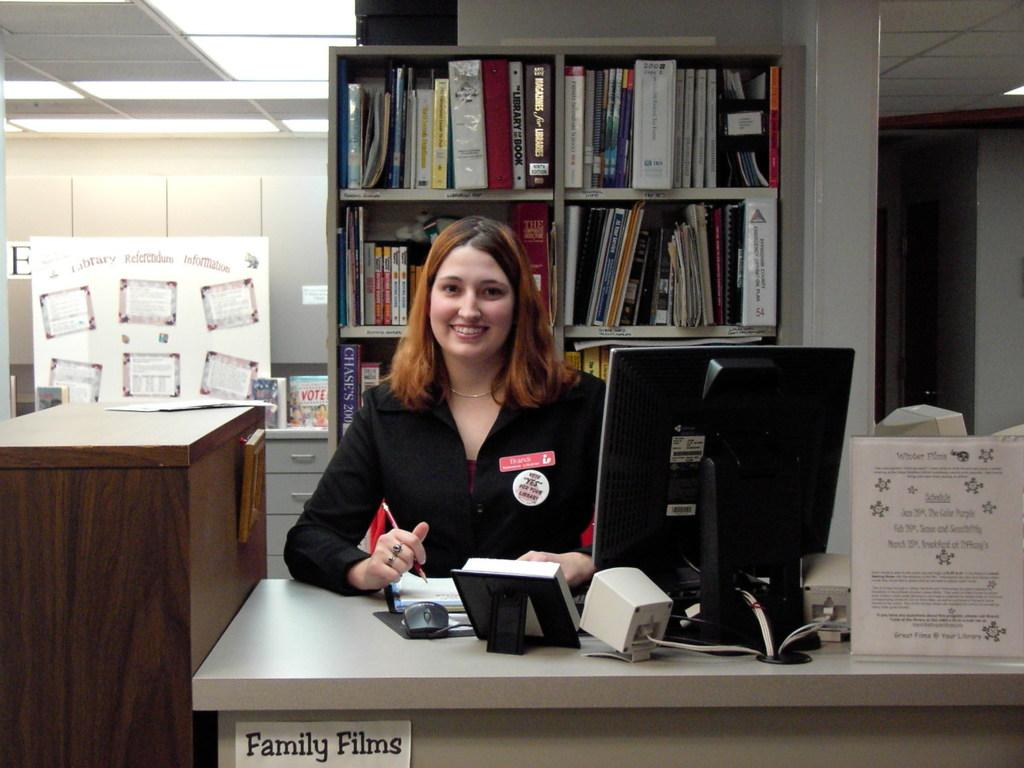<image>
Offer a succinct explanation of the picture presented. A young woman sits at a desk that is labelled "Family Films". 